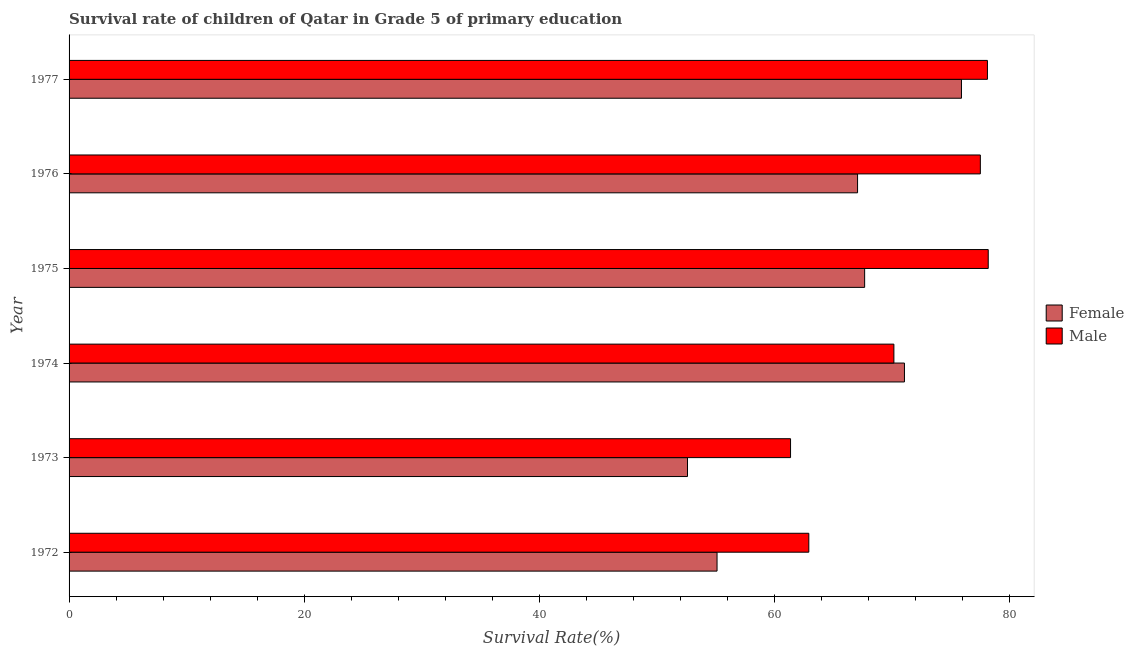Are the number of bars on each tick of the Y-axis equal?
Give a very brief answer. Yes. How many bars are there on the 2nd tick from the top?
Your response must be concise. 2. What is the label of the 1st group of bars from the top?
Offer a terse response. 1977. In how many cases, is the number of bars for a given year not equal to the number of legend labels?
Offer a terse response. 0. What is the survival rate of male students in primary education in 1977?
Your response must be concise. 78.09. Across all years, what is the maximum survival rate of female students in primary education?
Your response must be concise. 75.88. Across all years, what is the minimum survival rate of female students in primary education?
Provide a short and direct response. 52.59. In which year was the survival rate of female students in primary education maximum?
Provide a succinct answer. 1977. What is the total survival rate of male students in primary education in the graph?
Ensure brevity in your answer.  428.14. What is the difference between the survival rate of female students in primary education in 1975 and that in 1976?
Ensure brevity in your answer.  0.6. What is the difference between the survival rate of female students in primary education in 1975 and the survival rate of male students in primary education in 1973?
Give a very brief answer. 6.3. What is the average survival rate of male students in primary education per year?
Ensure brevity in your answer.  71.36. In the year 1974, what is the difference between the survival rate of male students in primary education and survival rate of female students in primary education?
Ensure brevity in your answer.  -0.9. What is the ratio of the survival rate of female students in primary education in 1975 to that in 1977?
Make the answer very short. 0.89. Is the survival rate of male students in primary education in 1973 less than that in 1977?
Your response must be concise. Yes. What is the difference between the highest and the second highest survival rate of male students in primary education?
Provide a short and direct response. 0.07. What is the difference between the highest and the lowest survival rate of female students in primary education?
Your answer should be compact. 23.3. In how many years, is the survival rate of male students in primary education greater than the average survival rate of male students in primary education taken over all years?
Offer a very short reply. 3. Is the sum of the survival rate of male students in primary education in 1975 and 1976 greater than the maximum survival rate of female students in primary education across all years?
Your response must be concise. Yes. What does the 2nd bar from the top in 1973 represents?
Your answer should be compact. Female. How many years are there in the graph?
Your response must be concise. 6. Are the values on the major ticks of X-axis written in scientific E-notation?
Provide a short and direct response. No. Does the graph contain grids?
Provide a short and direct response. No. Where does the legend appear in the graph?
Offer a very short reply. Center right. What is the title of the graph?
Provide a short and direct response. Survival rate of children of Qatar in Grade 5 of primary education. Does "National Visitors" appear as one of the legend labels in the graph?
Give a very brief answer. No. What is the label or title of the X-axis?
Your response must be concise. Survival Rate(%). What is the Survival Rate(%) in Female in 1972?
Give a very brief answer. 55.1. What is the Survival Rate(%) of Male in 1972?
Provide a short and direct response. 62.9. What is the Survival Rate(%) in Female in 1973?
Make the answer very short. 52.59. What is the Survival Rate(%) in Male in 1973?
Provide a succinct answer. 61.35. What is the Survival Rate(%) in Female in 1974?
Provide a short and direct response. 71.04. What is the Survival Rate(%) of Male in 1974?
Provide a short and direct response. 70.14. What is the Survival Rate(%) in Female in 1975?
Offer a terse response. 67.65. What is the Survival Rate(%) of Male in 1975?
Your response must be concise. 78.16. What is the Survival Rate(%) of Female in 1976?
Provide a short and direct response. 67.05. What is the Survival Rate(%) of Male in 1976?
Offer a terse response. 77.49. What is the Survival Rate(%) of Female in 1977?
Provide a short and direct response. 75.88. What is the Survival Rate(%) of Male in 1977?
Offer a terse response. 78.09. Across all years, what is the maximum Survival Rate(%) in Female?
Ensure brevity in your answer.  75.88. Across all years, what is the maximum Survival Rate(%) of Male?
Offer a very short reply. 78.16. Across all years, what is the minimum Survival Rate(%) of Female?
Your answer should be compact. 52.59. Across all years, what is the minimum Survival Rate(%) in Male?
Keep it short and to the point. 61.35. What is the total Survival Rate(%) in Female in the graph?
Make the answer very short. 389.31. What is the total Survival Rate(%) of Male in the graph?
Give a very brief answer. 428.14. What is the difference between the Survival Rate(%) of Female in 1972 and that in 1973?
Offer a terse response. 2.51. What is the difference between the Survival Rate(%) of Male in 1972 and that in 1973?
Ensure brevity in your answer.  1.55. What is the difference between the Survival Rate(%) in Female in 1972 and that in 1974?
Provide a succinct answer. -15.94. What is the difference between the Survival Rate(%) in Male in 1972 and that in 1974?
Your answer should be compact. -7.24. What is the difference between the Survival Rate(%) of Female in 1972 and that in 1975?
Provide a short and direct response. -12.55. What is the difference between the Survival Rate(%) of Male in 1972 and that in 1975?
Keep it short and to the point. -15.26. What is the difference between the Survival Rate(%) of Female in 1972 and that in 1976?
Ensure brevity in your answer.  -11.95. What is the difference between the Survival Rate(%) of Male in 1972 and that in 1976?
Provide a succinct answer. -14.59. What is the difference between the Survival Rate(%) in Female in 1972 and that in 1977?
Make the answer very short. -20.78. What is the difference between the Survival Rate(%) in Male in 1972 and that in 1977?
Provide a short and direct response. -15.19. What is the difference between the Survival Rate(%) in Female in 1973 and that in 1974?
Offer a terse response. -18.45. What is the difference between the Survival Rate(%) in Male in 1973 and that in 1974?
Keep it short and to the point. -8.79. What is the difference between the Survival Rate(%) of Female in 1973 and that in 1975?
Offer a very short reply. -15.06. What is the difference between the Survival Rate(%) in Male in 1973 and that in 1975?
Offer a very short reply. -16.81. What is the difference between the Survival Rate(%) of Female in 1973 and that in 1976?
Ensure brevity in your answer.  -14.46. What is the difference between the Survival Rate(%) of Male in 1973 and that in 1976?
Ensure brevity in your answer.  -16.14. What is the difference between the Survival Rate(%) in Female in 1973 and that in 1977?
Provide a succinct answer. -23.3. What is the difference between the Survival Rate(%) of Male in 1973 and that in 1977?
Give a very brief answer. -16.74. What is the difference between the Survival Rate(%) of Female in 1974 and that in 1975?
Your answer should be very brief. 3.39. What is the difference between the Survival Rate(%) in Male in 1974 and that in 1975?
Make the answer very short. -8.02. What is the difference between the Survival Rate(%) in Female in 1974 and that in 1976?
Your answer should be compact. 3.99. What is the difference between the Survival Rate(%) in Male in 1974 and that in 1976?
Ensure brevity in your answer.  -7.35. What is the difference between the Survival Rate(%) of Female in 1974 and that in 1977?
Provide a succinct answer. -4.85. What is the difference between the Survival Rate(%) of Male in 1974 and that in 1977?
Your answer should be compact. -7.95. What is the difference between the Survival Rate(%) in Female in 1975 and that in 1976?
Your answer should be very brief. 0.6. What is the difference between the Survival Rate(%) of Male in 1975 and that in 1976?
Your answer should be compact. 0.67. What is the difference between the Survival Rate(%) of Female in 1975 and that in 1977?
Ensure brevity in your answer.  -8.23. What is the difference between the Survival Rate(%) in Male in 1975 and that in 1977?
Provide a short and direct response. 0.07. What is the difference between the Survival Rate(%) in Female in 1976 and that in 1977?
Give a very brief answer. -8.84. What is the difference between the Survival Rate(%) in Male in 1976 and that in 1977?
Your response must be concise. -0.6. What is the difference between the Survival Rate(%) in Female in 1972 and the Survival Rate(%) in Male in 1973?
Give a very brief answer. -6.25. What is the difference between the Survival Rate(%) in Female in 1972 and the Survival Rate(%) in Male in 1974?
Your response must be concise. -15.04. What is the difference between the Survival Rate(%) of Female in 1972 and the Survival Rate(%) of Male in 1975?
Provide a short and direct response. -23.06. What is the difference between the Survival Rate(%) in Female in 1972 and the Survival Rate(%) in Male in 1976?
Make the answer very short. -22.39. What is the difference between the Survival Rate(%) in Female in 1972 and the Survival Rate(%) in Male in 1977?
Ensure brevity in your answer.  -22.99. What is the difference between the Survival Rate(%) in Female in 1973 and the Survival Rate(%) in Male in 1974?
Offer a very short reply. -17.55. What is the difference between the Survival Rate(%) of Female in 1973 and the Survival Rate(%) of Male in 1975?
Offer a terse response. -25.57. What is the difference between the Survival Rate(%) in Female in 1973 and the Survival Rate(%) in Male in 1976?
Offer a very short reply. -24.9. What is the difference between the Survival Rate(%) in Female in 1973 and the Survival Rate(%) in Male in 1977?
Your response must be concise. -25.5. What is the difference between the Survival Rate(%) in Female in 1974 and the Survival Rate(%) in Male in 1975?
Give a very brief answer. -7.12. What is the difference between the Survival Rate(%) of Female in 1974 and the Survival Rate(%) of Male in 1976?
Provide a short and direct response. -6.45. What is the difference between the Survival Rate(%) of Female in 1974 and the Survival Rate(%) of Male in 1977?
Your response must be concise. -7.06. What is the difference between the Survival Rate(%) in Female in 1975 and the Survival Rate(%) in Male in 1976?
Provide a succinct answer. -9.84. What is the difference between the Survival Rate(%) of Female in 1975 and the Survival Rate(%) of Male in 1977?
Ensure brevity in your answer.  -10.44. What is the difference between the Survival Rate(%) of Female in 1976 and the Survival Rate(%) of Male in 1977?
Your response must be concise. -11.04. What is the average Survival Rate(%) in Female per year?
Offer a very short reply. 64.88. What is the average Survival Rate(%) in Male per year?
Provide a short and direct response. 71.36. In the year 1972, what is the difference between the Survival Rate(%) in Female and Survival Rate(%) in Male?
Make the answer very short. -7.8. In the year 1973, what is the difference between the Survival Rate(%) in Female and Survival Rate(%) in Male?
Give a very brief answer. -8.76. In the year 1974, what is the difference between the Survival Rate(%) of Female and Survival Rate(%) of Male?
Your answer should be compact. 0.9. In the year 1975, what is the difference between the Survival Rate(%) in Female and Survival Rate(%) in Male?
Offer a terse response. -10.51. In the year 1976, what is the difference between the Survival Rate(%) in Female and Survival Rate(%) in Male?
Your answer should be very brief. -10.44. In the year 1977, what is the difference between the Survival Rate(%) of Female and Survival Rate(%) of Male?
Your answer should be compact. -2.21. What is the ratio of the Survival Rate(%) in Female in 1972 to that in 1973?
Ensure brevity in your answer.  1.05. What is the ratio of the Survival Rate(%) in Male in 1972 to that in 1973?
Your answer should be very brief. 1.03. What is the ratio of the Survival Rate(%) in Female in 1972 to that in 1974?
Your answer should be very brief. 0.78. What is the ratio of the Survival Rate(%) of Male in 1972 to that in 1974?
Your answer should be compact. 0.9. What is the ratio of the Survival Rate(%) of Female in 1972 to that in 1975?
Provide a succinct answer. 0.81. What is the ratio of the Survival Rate(%) of Male in 1972 to that in 1975?
Your response must be concise. 0.8. What is the ratio of the Survival Rate(%) of Female in 1972 to that in 1976?
Your answer should be compact. 0.82. What is the ratio of the Survival Rate(%) of Male in 1972 to that in 1976?
Your answer should be compact. 0.81. What is the ratio of the Survival Rate(%) of Female in 1972 to that in 1977?
Keep it short and to the point. 0.73. What is the ratio of the Survival Rate(%) of Male in 1972 to that in 1977?
Your response must be concise. 0.81. What is the ratio of the Survival Rate(%) of Female in 1973 to that in 1974?
Provide a short and direct response. 0.74. What is the ratio of the Survival Rate(%) in Male in 1973 to that in 1974?
Your response must be concise. 0.87. What is the ratio of the Survival Rate(%) of Female in 1973 to that in 1975?
Offer a terse response. 0.78. What is the ratio of the Survival Rate(%) of Male in 1973 to that in 1975?
Your answer should be compact. 0.78. What is the ratio of the Survival Rate(%) in Female in 1973 to that in 1976?
Ensure brevity in your answer.  0.78. What is the ratio of the Survival Rate(%) of Male in 1973 to that in 1976?
Offer a terse response. 0.79. What is the ratio of the Survival Rate(%) of Female in 1973 to that in 1977?
Give a very brief answer. 0.69. What is the ratio of the Survival Rate(%) of Male in 1973 to that in 1977?
Offer a very short reply. 0.79. What is the ratio of the Survival Rate(%) in Female in 1974 to that in 1975?
Make the answer very short. 1.05. What is the ratio of the Survival Rate(%) in Male in 1974 to that in 1975?
Offer a very short reply. 0.9. What is the ratio of the Survival Rate(%) in Female in 1974 to that in 1976?
Provide a short and direct response. 1.06. What is the ratio of the Survival Rate(%) in Male in 1974 to that in 1976?
Give a very brief answer. 0.91. What is the ratio of the Survival Rate(%) in Female in 1974 to that in 1977?
Offer a terse response. 0.94. What is the ratio of the Survival Rate(%) of Male in 1974 to that in 1977?
Give a very brief answer. 0.9. What is the ratio of the Survival Rate(%) in Female in 1975 to that in 1976?
Ensure brevity in your answer.  1.01. What is the ratio of the Survival Rate(%) of Male in 1975 to that in 1976?
Your answer should be compact. 1.01. What is the ratio of the Survival Rate(%) in Female in 1975 to that in 1977?
Ensure brevity in your answer.  0.89. What is the ratio of the Survival Rate(%) in Male in 1975 to that in 1977?
Your answer should be very brief. 1. What is the ratio of the Survival Rate(%) in Female in 1976 to that in 1977?
Ensure brevity in your answer.  0.88. What is the difference between the highest and the second highest Survival Rate(%) of Female?
Offer a very short reply. 4.85. What is the difference between the highest and the second highest Survival Rate(%) of Male?
Your response must be concise. 0.07. What is the difference between the highest and the lowest Survival Rate(%) in Female?
Make the answer very short. 23.3. What is the difference between the highest and the lowest Survival Rate(%) of Male?
Ensure brevity in your answer.  16.81. 